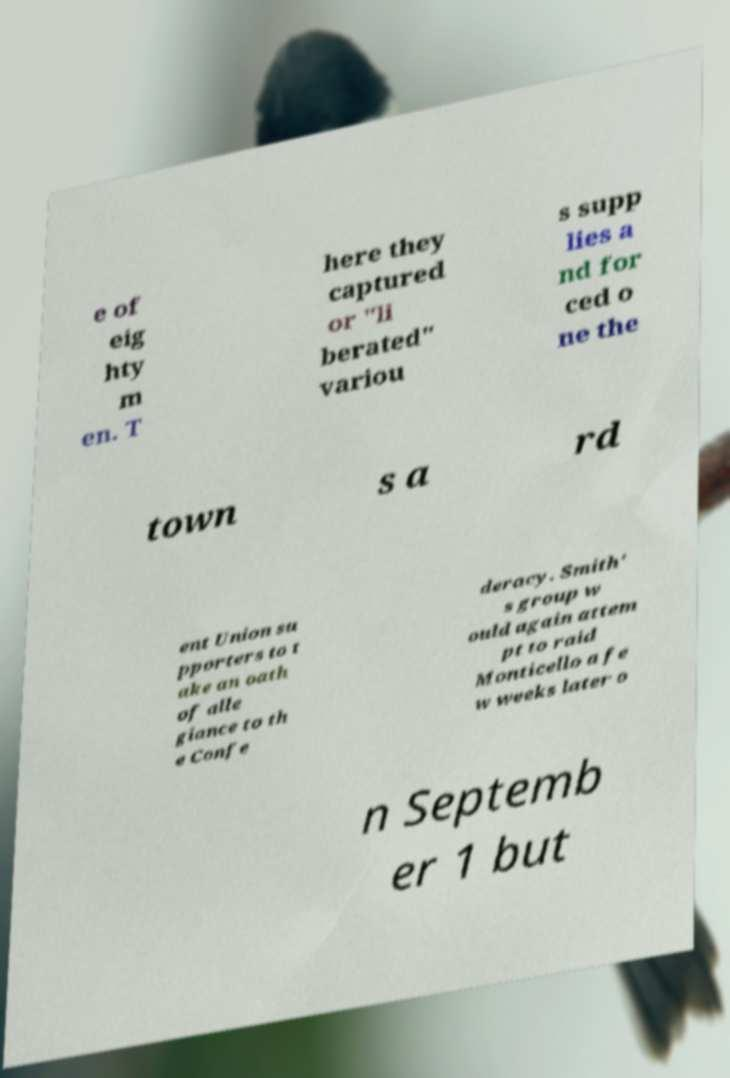What messages or text are displayed in this image? I need them in a readable, typed format. e of eig hty m en. T here they captured or "li berated" variou s supp lies a nd for ced o ne the town s a rd ent Union su pporters to t ake an oath of alle giance to th e Confe deracy. Smith' s group w ould again attem pt to raid Monticello a fe w weeks later o n Septemb er 1 but 